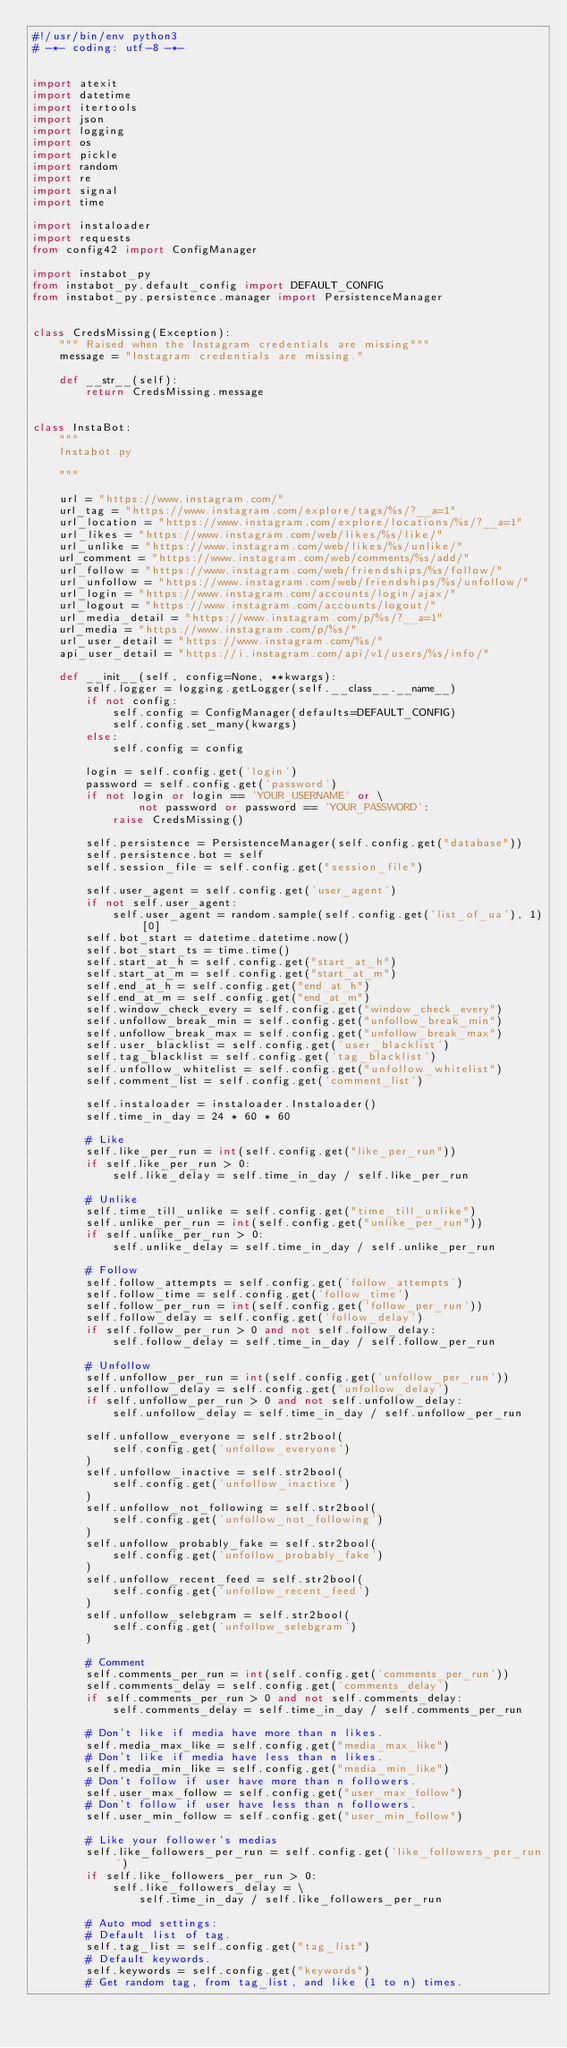<code> <loc_0><loc_0><loc_500><loc_500><_Python_>#!/usr/bin/env python3
# -*- coding: utf-8 -*-


import atexit
import datetime
import itertools
import json
import logging
import os
import pickle
import random
import re
import signal
import time

import instaloader
import requests
from config42 import ConfigManager

import instabot_py
from instabot_py.default_config import DEFAULT_CONFIG
from instabot_py.persistence.manager import PersistenceManager


class CredsMissing(Exception):
    """ Raised when the Instagram credentials are missing"""
    message = "Instagram credentials are missing."

    def __str__(self):
        return CredsMissing.message


class InstaBot:
    """
    Instabot.py

    """

    url = "https://www.instagram.com/"
    url_tag = "https://www.instagram.com/explore/tags/%s/?__a=1"
    url_location = "https://www.instagram.com/explore/locations/%s/?__a=1"
    url_likes = "https://www.instagram.com/web/likes/%s/like/"
    url_unlike = "https://www.instagram.com/web/likes/%s/unlike/"
    url_comment = "https://www.instagram.com/web/comments/%s/add/"
    url_follow = "https://www.instagram.com/web/friendships/%s/follow/"
    url_unfollow = "https://www.instagram.com/web/friendships/%s/unfollow/"
    url_login = "https://www.instagram.com/accounts/login/ajax/"
    url_logout = "https://www.instagram.com/accounts/logout/"
    url_media_detail = "https://www.instagram.com/p/%s/?__a=1"
    url_media = "https://www.instagram.com/p/%s/"
    url_user_detail = "https://www.instagram.com/%s/"
    api_user_detail = "https://i.instagram.com/api/v1/users/%s/info/"

    def __init__(self, config=None, **kwargs):
        self.logger = logging.getLogger(self.__class__.__name__)
        if not config:
            self.config = ConfigManager(defaults=DEFAULT_CONFIG)
            self.config.set_many(kwargs)
        else:
            self.config = config

        login = self.config.get('login')
        password = self.config.get('password')
        if not login or login == 'YOUR_USERNAME' or \
                not password or password == 'YOUR_PASSWORD':
            raise CredsMissing()

        self.persistence = PersistenceManager(self.config.get("database"))
        self.persistence.bot = self
        self.session_file = self.config.get("session_file")

        self.user_agent = self.config.get('user_agent')
        if not self.user_agent:
            self.user_agent = random.sample(self.config.get('list_of_ua'), 1)[0]
        self.bot_start = datetime.datetime.now()
        self.bot_start_ts = time.time()
        self.start_at_h = self.config.get("start_at_h")
        self.start_at_m = self.config.get("start_at_m")
        self.end_at_h = self.config.get("end_at_h")
        self.end_at_m = self.config.get("end_at_m")
        self.window_check_every = self.config.get("window_check_every")
        self.unfollow_break_min = self.config.get("unfollow_break_min")
        self.unfollow_break_max = self.config.get("unfollow_break_max")
        self.user_blacklist = self.config.get('user_blacklist')
        self.tag_blacklist = self.config.get('tag_blacklist')
        self.unfollow_whitelist = self.config.get("unfollow_whitelist")
        self.comment_list = self.config.get('comment_list')

        self.instaloader = instaloader.Instaloader()
        self.time_in_day = 24 * 60 * 60

        # Like
        self.like_per_run = int(self.config.get("like_per_run"))
        if self.like_per_run > 0:
            self.like_delay = self.time_in_day / self.like_per_run

        # Unlike
        self.time_till_unlike = self.config.get("time_till_unlike")
        self.unlike_per_run = int(self.config.get("unlike_per_run"))
        if self.unlike_per_run > 0:
            self.unlike_delay = self.time_in_day / self.unlike_per_run

        # Follow
        self.follow_attempts = self.config.get('follow_attempts')
        self.follow_time = self.config.get('follow_time')
        self.follow_per_run = int(self.config.get('follow_per_run'))
        self.follow_delay = self.config.get('follow_delay')
        if self.follow_per_run > 0 and not self.follow_delay:
            self.follow_delay = self.time_in_day / self.follow_per_run

        # Unfollow
        self.unfollow_per_run = int(self.config.get('unfollow_per_run'))
        self.unfollow_delay = self.config.get('unfollow_delay')
        if self.unfollow_per_run > 0 and not self.unfollow_delay:
            self.unfollow_delay = self.time_in_day / self.unfollow_per_run

        self.unfollow_everyone = self.str2bool(
            self.config.get('unfollow_everyone')
        )
        self.unfollow_inactive = self.str2bool(
            self.config.get('unfollow_inactive')
        )
        self.unfollow_not_following = self.str2bool(
            self.config.get('unfollow_not_following')
        )
        self.unfollow_probably_fake = self.str2bool(
            self.config.get('unfollow_probably_fake')
        )
        self.unfollow_recent_feed = self.str2bool(
            self.config.get('unfollow_recent_feed')
        )
        self.unfollow_selebgram = self.str2bool(
            self.config.get('unfollow_selebgram')
        )

        # Comment
        self.comments_per_run = int(self.config.get('comments_per_run'))
        self.comments_delay = self.config.get('comments_delay')
        if self.comments_per_run > 0 and not self.comments_delay:
            self.comments_delay = self.time_in_day / self.comments_per_run

        # Don't like if media have more than n likes.
        self.media_max_like = self.config.get("media_max_like")
        # Don't like if media have less than n likes.
        self.media_min_like = self.config.get("media_min_like")
        # Don't follow if user have more than n followers.
        self.user_max_follow = self.config.get("user_max_follow")
        # Don't follow if user have less than n followers.
        self.user_min_follow = self.config.get("user_min_follow")

        # Like your follower's medias
        self.like_followers_per_run = self.config.get('like_followers_per_run')
        if self.like_followers_per_run > 0:
            self.like_followers_delay = \
                self.time_in_day / self.like_followers_per_run

        # Auto mod settings:
        # Default list of tag.
        self.tag_list = self.config.get("tag_list")
        # Default keywords.
        self.keywords = self.config.get("keywords")
        # Get random tag, from tag_list, and like (1 to n) times.</code> 